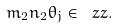<formula> <loc_0><loc_0><loc_500><loc_500>m _ { 2 } n _ { 2 } \theta _ { j } \in \ z z .</formula> 